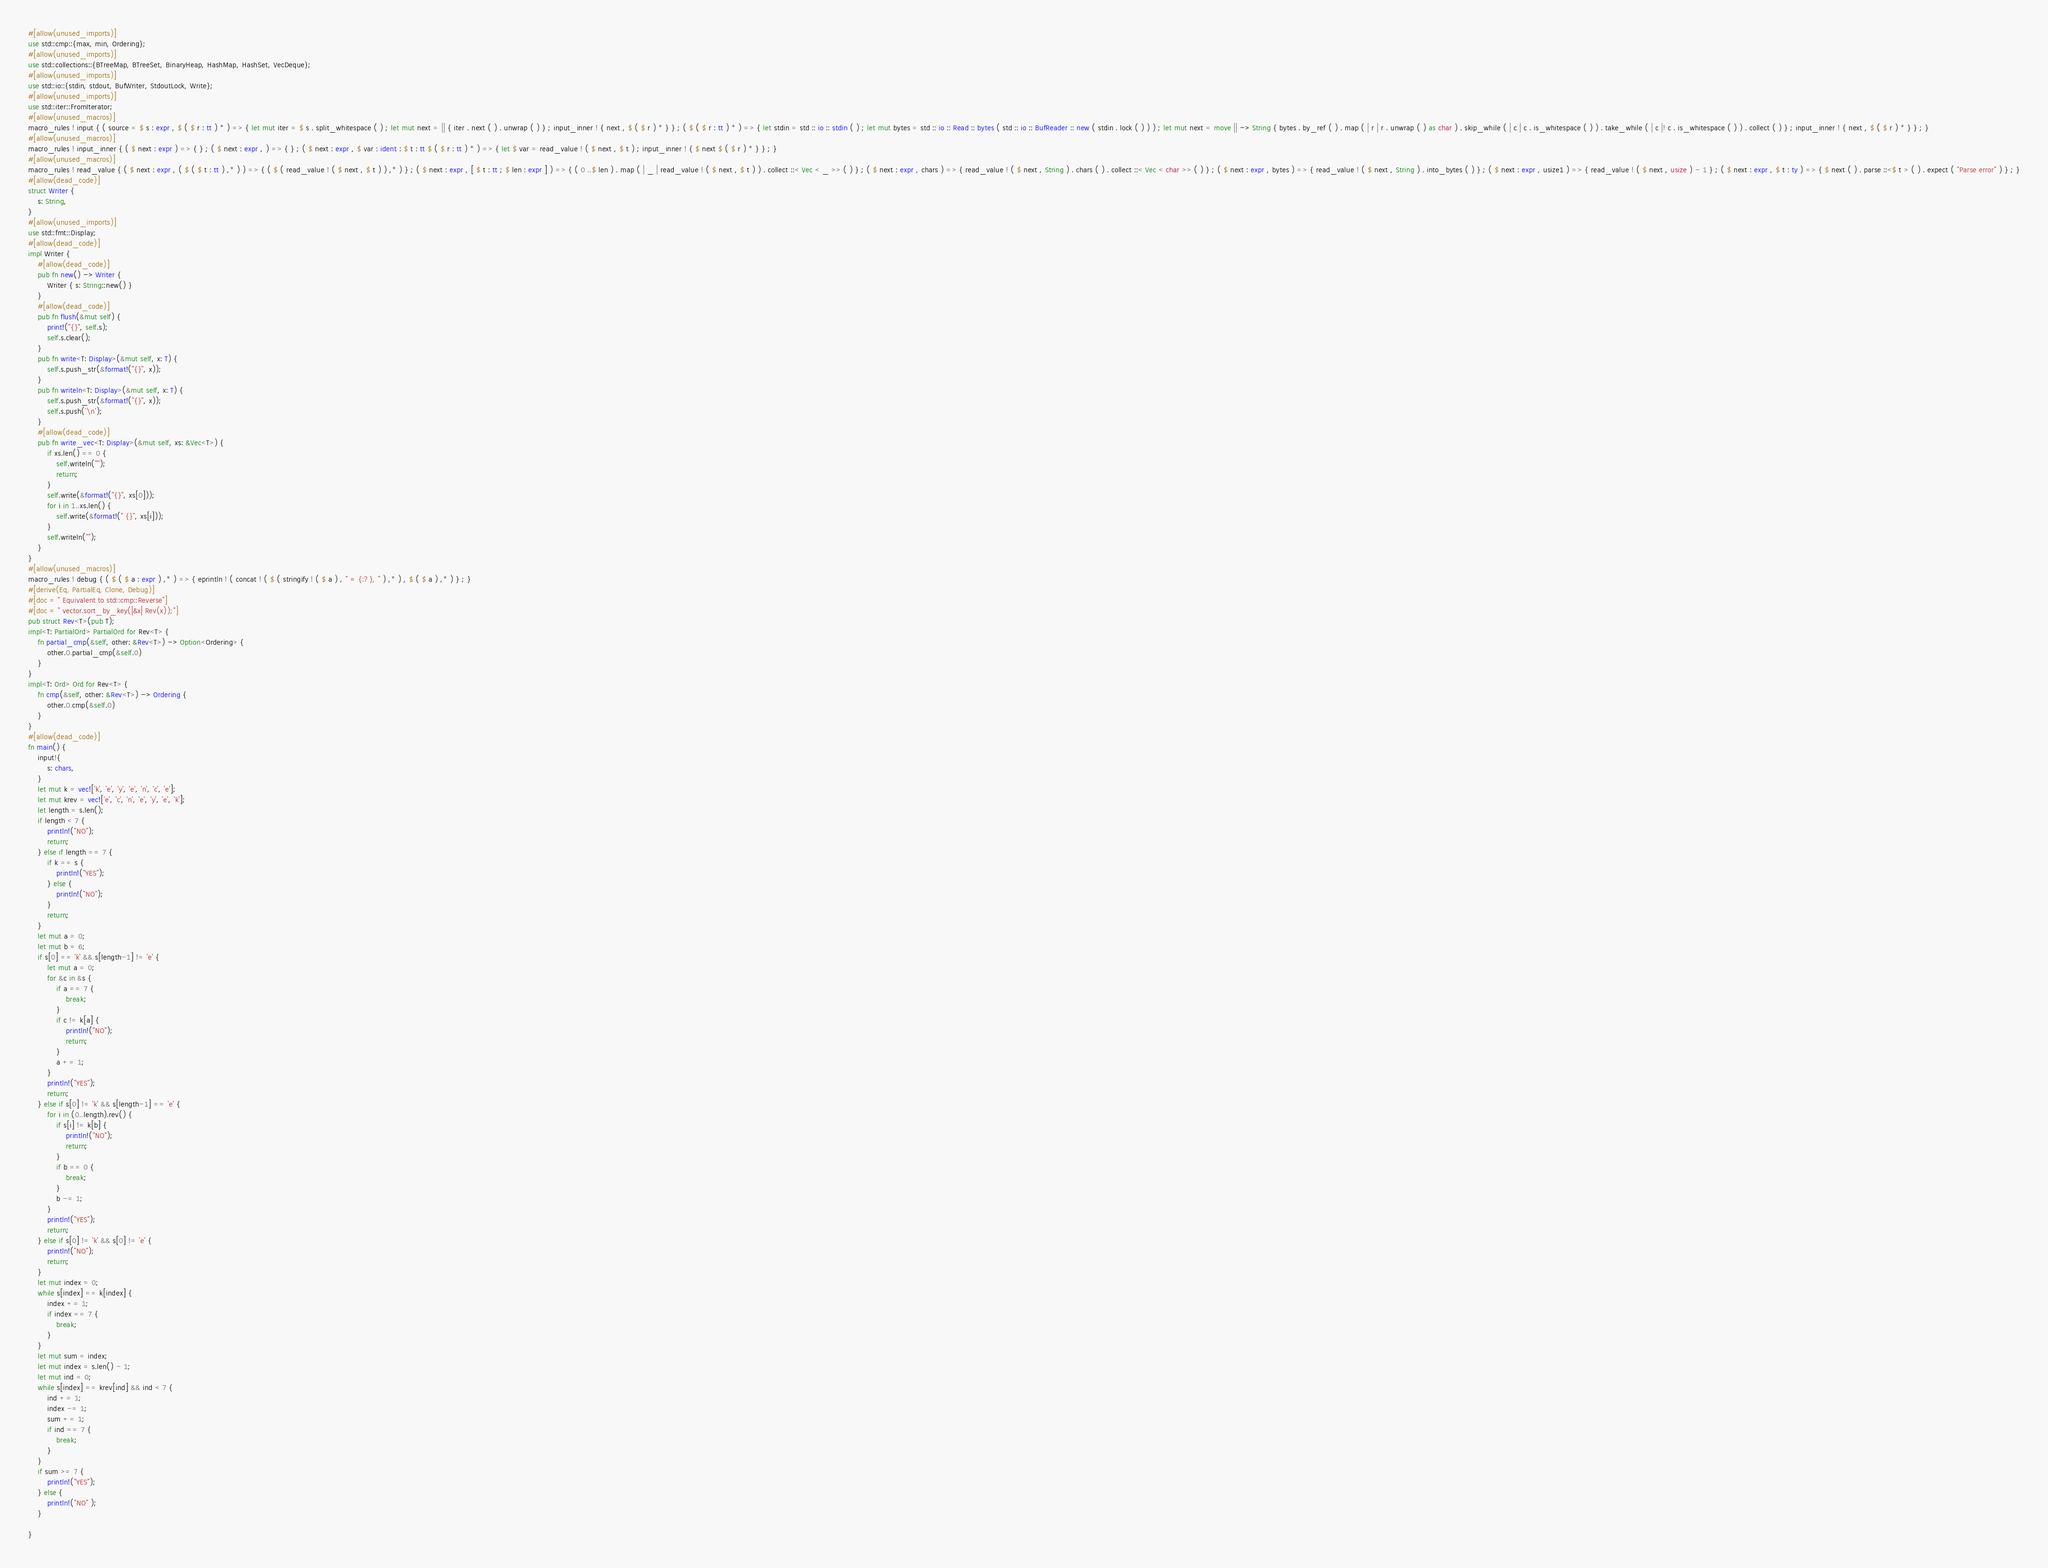<code> <loc_0><loc_0><loc_500><loc_500><_Rust_>#[allow(unused_imports)]
use std::cmp::{max, min, Ordering};
#[allow(unused_imports)]
use std::collections::{BTreeMap, BTreeSet, BinaryHeap, HashMap, HashSet, VecDeque};
#[allow(unused_imports)]
use std::io::{stdin, stdout, BufWriter, StdoutLock, Write};
#[allow(unused_imports)]
use std::iter::FromIterator;
#[allow(unused_macros)]
macro_rules ! input { ( source = $ s : expr , $ ( $ r : tt ) * ) => { let mut iter = $ s . split_whitespace ( ) ; let mut next = || { iter . next ( ) . unwrap ( ) } ; input_inner ! { next , $ ( $ r ) * } } ; ( $ ( $ r : tt ) * ) => { let stdin = std :: io :: stdin ( ) ; let mut bytes = std :: io :: Read :: bytes ( std :: io :: BufReader :: new ( stdin . lock ( ) ) ) ; let mut next = move || -> String { bytes . by_ref ( ) . map ( | r | r . unwrap ( ) as char ) . skip_while ( | c | c . is_whitespace ( ) ) . take_while ( | c |! c . is_whitespace ( ) ) . collect ( ) } ; input_inner ! { next , $ ( $ r ) * } } ; }
#[allow(unused_macros)]
macro_rules ! input_inner { ( $ next : expr ) => { } ; ( $ next : expr , ) => { } ; ( $ next : expr , $ var : ident : $ t : tt $ ( $ r : tt ) * ) => { let $ var = read_value ! ( $ next , $ t ) ; input_inner ! { $ next $ ( $ r ) * } } ; }
#[allow(unused_macros)]
macro_rules ! read_value { ( $ next : expr , ( $ ( $ t : tt ) ,* ) ) => { ( $ ( read_value ! ( $ next , $ t ) ) ,* ) } ; ( $ next : expr , [ $ t : tt ; $ len : expr ] ) => { ( 0 ..$ len ) . map ( | _ | read_value ! ( $ next , $ t ) ) . collect ::< Vec < _ >> ( ) } ; ( $ next : expr , chars ) => { read_value ! ( $ next , String ) . chars ( ) . collect ::< Vec < char >> ( ) } ; ( $ next : expr , bytes ) => { read_value ! ( $ next , String ) . into_bytes ( ) } ; ( $ next : expr , usize1 ) => { read_value ! ( $ next , usize ) - 1 } ; ( $ next : expr , $ t : ty ) => { $ next ( ) . parse ::<$ t > ( ) . expect ( "Parse error" ) } ; }
#[allow(dead_code)]
struct Writer {
    s: String,
}
#[allow(unused_imports)]
use std::fmt::Display;
#[allow(dead_code)]
impl Writer {
    #[allow(dead_code)]
    pub fn new() -> Writer {
        Writer { s: String::new() }
    }
    #[allow(dead_code)]
    pub fn flush(&mut self) {
        print!("{}", self.s);
        self.s.clear();
    }
    pub fn write<T: Display>(&mut self, x: T) {
        self.s.push_str(&format!("{}", x));
    }
    pub fn writeln<T: Display>(&mut self, x: T) {
        self.s.push_str(&format!("{}", x));
        self.s.push('\n');
    }
    #[allow(dead_code)]
    pub fn write_vec<T: Display>(&mut self, xs: &Vec<T>) {
        if xs.len() == 0 {
            self.writeln("");
            return;
        }
        self.write(&format!("{}", xs[0]));
        for i in 1..xs.len() {
            self.write(&format!(" {}", xs[i]));
        }
        self.writeln("");
    }
}
#[allow(unused_macros)]
macro_rules ! debug { ( $ ( $ a : expr ) ,* ) => { eprintln ! ( concat ! ( $ ( stringify ! ( $ a ) , " = {:?}, " ) ,* ) , $ ( $ a ) ,* ) } ; }
#[derive(Eq, PartialEq, Clone, Debug)]
#[doc = " Equivalent to std::cmp::Reverse"]
#[doc = " vector.sort_by_key(|&x| Rev(x));"]
pub struct Rev<T>(pub T);
impl<T: PartialOrd> PartialOrd for Rev<T> {
    fn partial_cmp(&self, other: &Rev<T>) -> Option<Ordering> {
        other.0.partial_cmp(&self.0)
    }
}
impl<T: Ord> Ord for Rev<T> {
    fn cmp(&self, other: &Rev<T>) -> Ordering {
        other.0.cmp(&self.0)
    }
}
#[allow(dead_code)]
fn main() {
    input!{
        s: chars,
    }
    let mut k = vec!['k', 'e', 'y', 'e', 'n', 'c', 'e'];
    let mut krev = vec!['e', 'c', 'n', 'e', 'y', 'e', 'k'];
    let length = s.len();
    if length < 7 {
        println!("NO");
        return;
    } else if length == 7 {
        if k == s {
            println!("YES");
        } else {
            println!("NO");
        }
        return;
    }
    let mut a = 0;
    let mut b = 6;
    if s[0] == 'k' && s[length-1] != 'e' {
        let mut a = 0;
        for &c in &s {
            if a == 7 {
                break;
            }
            if c != k[a] {
                println!("NO");
                return;
            }
            a += 1;
        }
        println!("YES");
        return;
    } else if s[0] != 'k' && s[length-1] == 'e' {
        for i in (0..length).rev() {
            if s[i] != k[b] {
                println!("NO");
                return;
            }
            if b == 0 {
                break;
            }
            b -= 1;
        }
        println!("YES");
        return;
    } else if s[0] != 'k' && s[0] != 'e' {
        println!("NO");
        return;
    }
    let mut index = 0;
    while s[index] == k[index] {
        index += 1;
        if index == 7 {
            break;
        }
    }
    let mut sum = index;
    let mut index = s.len() - 1;
    let mut ind = 0;
    while s[index] == krev[ind] && ind < 7 {
        ind += 1;
        index -= 1;
        sum += 1;
        if ind == 7 {
            break;
        }
    }
    if sum >= 7 {
        println!("YES");
    } else {
        println!("NO" );
    }

}</code> 